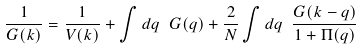Convert formula to latex. <formula><loc_0><loc_0><loc_500><loc_500>\frac { 1 } { G ( k ) } = \frac { 1 } { V ( k ) } + \int d q \ G ( q ) + \frac { 2 } { N } \int d q \ \frac { G ( k - q ) } { 1 + \Pi ( q ) }</formula> 